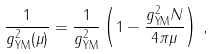Convert formula to latex. <formula><loc_0><loc_0><loc_500><loc_500>\frac { 1 } { g ^ { 2 } _ { \text {YM} } ( \mu ) } = \frac { 1 } { g ^ { 2 } _ { \text {YM} } } \left ( 1 - \frac { g ^ { 2 } _ { \text {YM} } N } { 4 \pi \mu } \right ) \, ,</formula> 